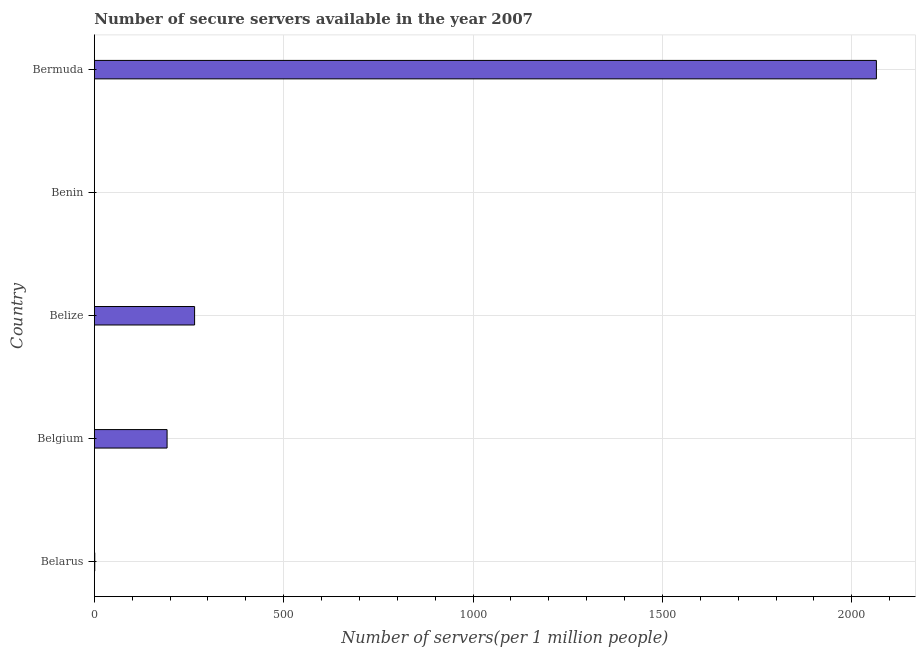Does the graph contain any zero values?
Provide a short and direct response. No. Does the graph contain grids?
Ensure brevity in your answer.  Yes. What is the title of the graph?
Your answer should be very brief. Number of secure servers available in the year 2007. What is the label or title of the X-axis?
Make the answer very short. Number of servers(per 1 million people). What is the label or title of the Y-axis?
Offer a very short reply. Country. What is the number of secure internet servers in Bermuda?
Your response must be concise. 2065.1. Across all countries, what is the maximum number of secure internet servers?
Make the answer very short. 2065.1. Across all countries, what is the minimum number of secure internet servers?
Ensure brevity in your answer.  0.11. In which country was the number of secure internet servers maximum?
Your answer should be compact. Bermuda. In which country was the number of secure internet servers minimum?
Your answer should be compact. Benin. What is the sum of the number of secure internet servers?
Offer a very short reply. 2523.19. What is the difference between the number of secure internet servers in Belgium and Belize?
Provide a short and direct response. -72.66. What is the average number of secure internet servers per country?
Your answer should be compact. 504.64. What is the median number of secure internet servers?
Offer a terse response. 192.08. In how many countries, is the number of secure internet servers greater than 1000 ?
Provide a succinct answer. 1. What is the ratio of the number of secure internet servers in Belarus to that in Belgium?
Your answer should be compact. 0.01. Is the number of secure internet servers in Belize less than that in Bermuda?
Offer a terse response. Yes. What is the difference between the highest and the second highest number of secure internet servers?
Your answer should be very brief. 1800.35. Is the sum of the number of secure internet servers in Belgium and Belize greater than the maximum number of secure internet servers across all countries?
Keep it short and to the point. No. What is the difference between the highest and the lowest number of secure internet servers?
Offer a very short reply. 2064.98. Are all the bars in the graph horizontal?
Offer a terse response. Yes. What is the Number of servers(per 1 million people) of Belarus?
Provide a short and direct response. 1.15. What is the Number of servers(per 1 million people) of Belgium?
Your answer should be compact. 192.08. What is the Number of servers(per 1 million people) in Belize?
Keep it short and to the point. 264.74. What is the Number of servers(per 1 million people) of Benin?
Provide a succinct answer. 0.11. What is the Number of servers(per 1 million people) in Bermuda?
Offer a very short reply. 2065.1. What is the difference between the Number of servers(per 1 million people) in Belarus and Belgium?
Offer a very short reply. -190.93. What is the difference between the Number of servers(per 1 million people) in Belarus and Belize?
Give a very brief answer. -263.59. What is the difference between the Number of servers(per 1 million people) in Belarus and Benin?
Provide a short and direct response. 1.04. What is the difference between the Number of servers(per 1 million people) in Belarus and Bermuda?
Ensure brevity in your answer.  -2063.95. What is the difference between the Number of servers(per 1 million people) in Belgium and Belize?
Ensure brevity in your answer.  -72.66. What is the difference between the Number of servers(per 1 million people) in Belgium and Benin?
Provide a succinct answer. 191.97. What is the difference between the Number of servers(per 1 million people) in Belgium and Bermuda?
Provide a short and direct response. -1873.02. What is the difference between the Number of servers(per 1 million people) in Belize and Benin?
Provide a succinct answer. 264.63. What is the difference between the Number of servers(per 1 million people) in Belize and Bermuda?
Your answer should be very brief. -1800.35. What is the difference between the Number of servers(per 1 million people) in Benin and Bermuda?
Ensure brevity in your answer.  -2064.98. What is the ratio of the Number of servers(per 1 million people) in Belarus to that in Belgium?
Your answer should be compact. 0.01. What is the ratio of the Number of servers(per 1 million people) in Belarus to that in Belize?
Provide a short and direct response. 0. What is the ratio of the Number of servers(per 1 million people) in Belarus to that in Benin?
Offer a very short reply. 10.02. What is the ratio of the Number of servers(per 1 million people) in Belarus to that in Bermuda?
Provide a short and direct response. 0. What is the ratio of the Number of servers(per 1 million people) in Belgium to that in Belize?
Give a very brief answer. 0.73. What is the ratio of the Number of servers(per 1 million people) in Belgium to that in Benin?
Your answer should be compact. 1672.58. What is the ratio of the Number of servers(per 1 million people) in Belgium to that in Bermuda?
Keep it short and to the point. 0.09. What is the ratio of the Number of servers(per 1 million people) in Belize to that in Benin?
Offer a very short reply. 2305.28. What is the ratio of the Number of servers(per 1 million people) in Belize to that in Bermuda?
Keep it short and to the point. 0.13. What is the ratio of the Number of servers(per 1 million people) in Benin to that in Bermuda?
Give a very brief answer. 0. 